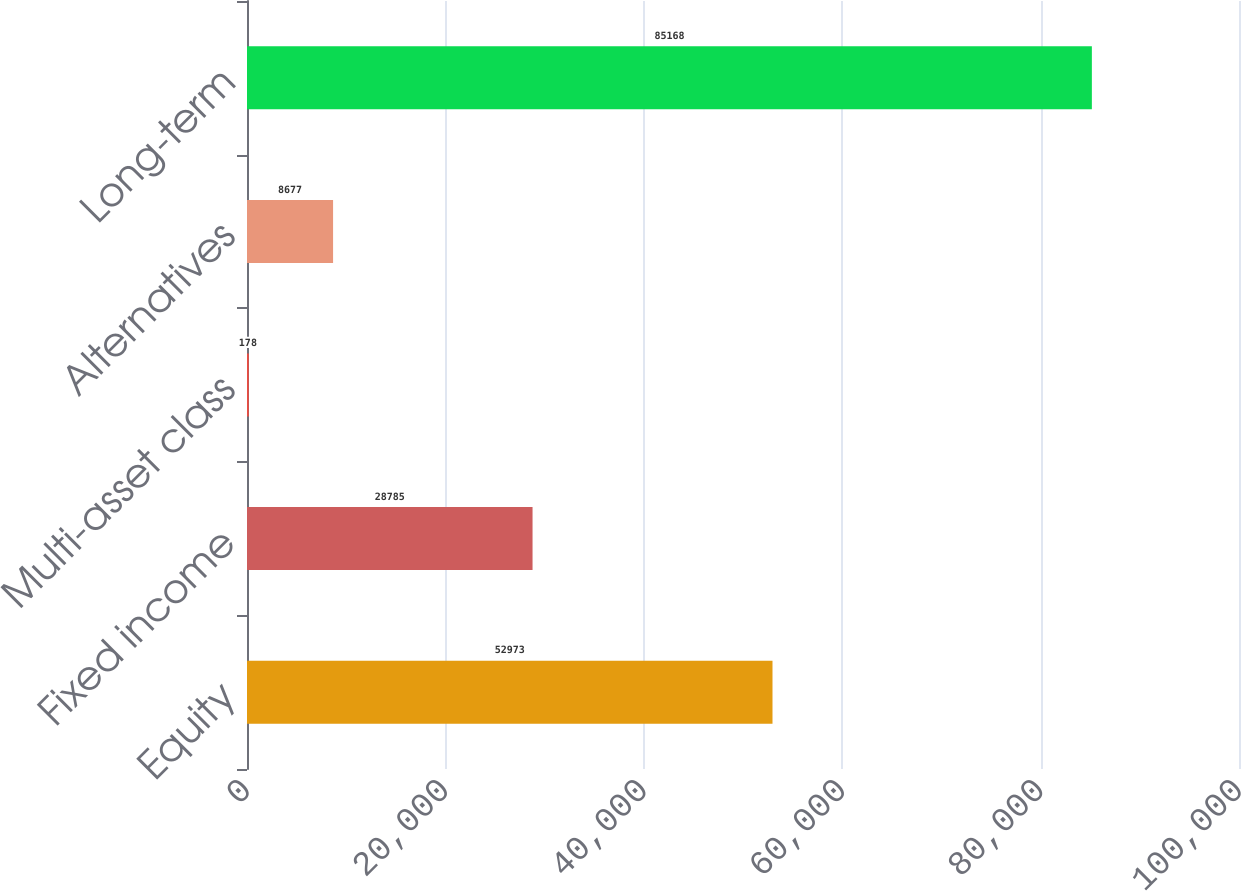Convert chart to OTSL. <chart><loc_0><loc_0><loc_500><loc_500><bar_chart><fcel>Equity<fcel>Fixed income<fcel>Multi-asset class<fcel>Alternatives<fcel>Long-term<nl><fcel>52973<fcel>28785<fcel>178<fcel>8677<fcel>85168<nl></chart> 